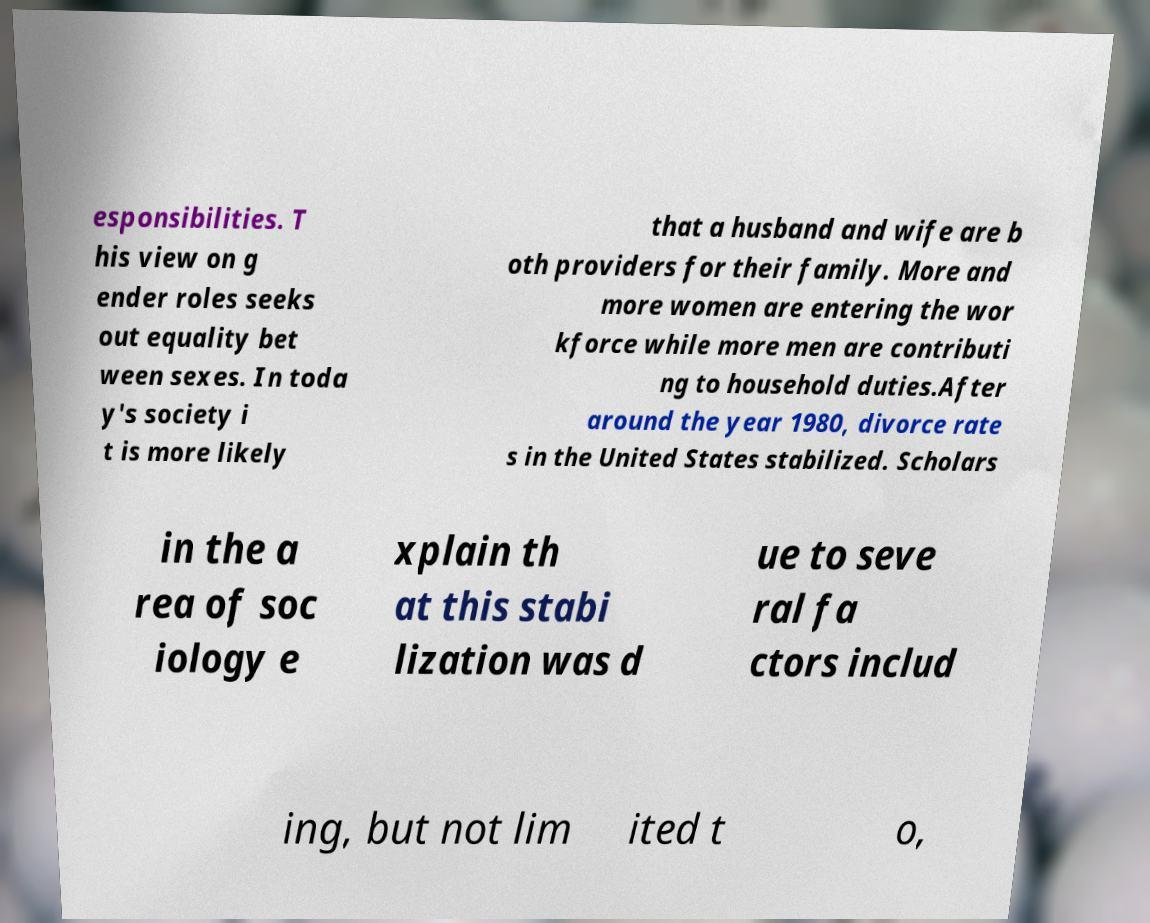There's text embedded in this image that I need extracted. Can you transcribe it verbatim? esponsibilities. T his view on g ender roles seeks out equality bet ween sexes. In toda y's society i t is more likely that a husband and wife are b oth providers for their family. More and more women are entering the wor kforce while more men are contributi ng to household duties.After around the year 1980, divorce rate s in the United States stabilized. Scholars in the a rea of soc iology e xplain th at this stabi lization was d ue to seve ral fa ctors includ ing, but not lim ited t o, 